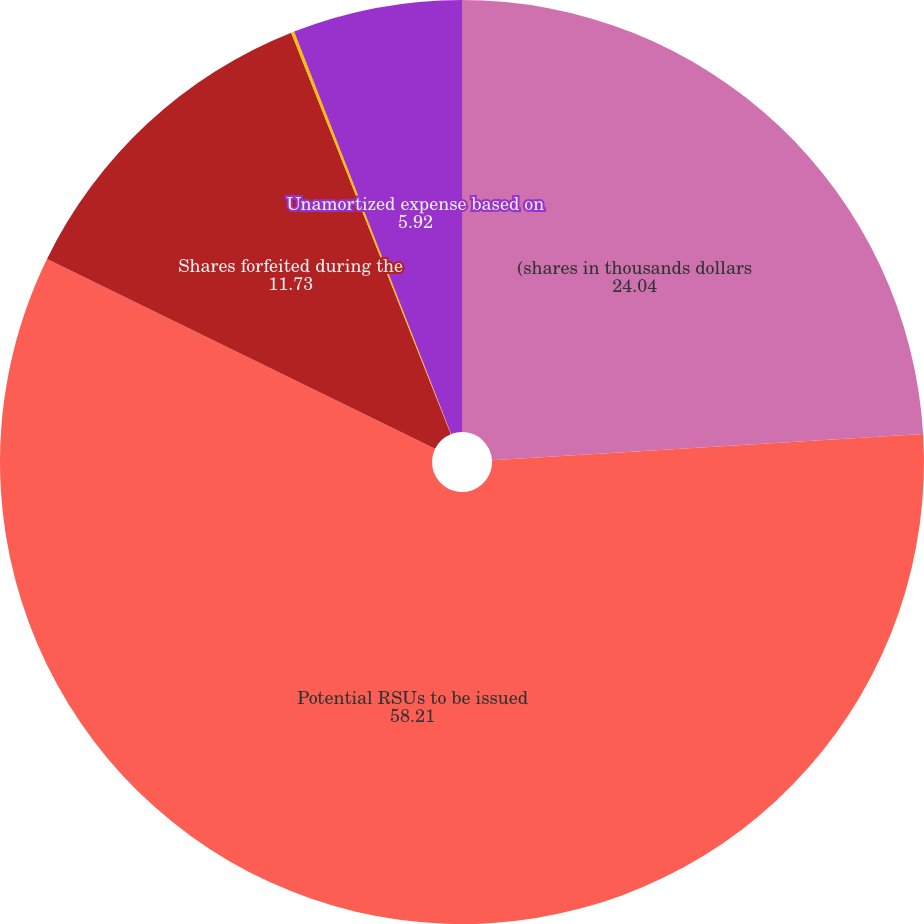Convert chart to OTSL. <chart><loc_0><loc_0><loc_500><loc_500><pie_chart><fcel>(shares in thousands dollars<fcel>Potential RSUs to be issued<fcel>Shares forfeited during the<fcel>RSUs awarded during the year<fcel>Unamortized expense based on<nl><fcel>24.04%<fcel>58.21%<fcel>11.73%<fcel>0.11%<fcel>5.92%<nl></chart> 